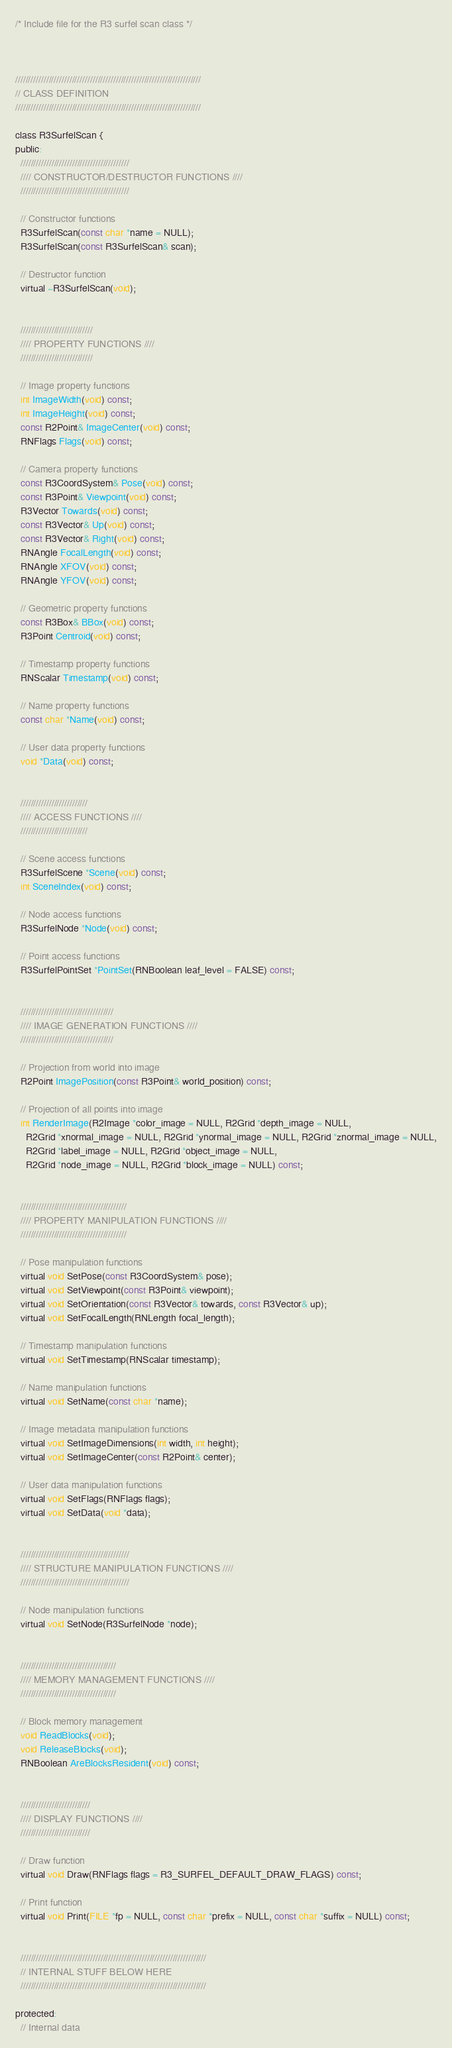Convert code to text. <code><loc_0><loc_0><loc_500><loc_500><_C_>/* Include file for the R3 surfel scan class */



////////////////////////////////////////////////////////////////////////
// CLASS DEFINITION
////////////////////////////////////////////////////////////////////////

class R3SurfelScan {
public:
  //////////////////////////////////////////
  //// CONSTRUCTOR/DESTRUCTOR FUNCTIONS ////
  //////////////////////////////////////////

  // Constructor functions
  R3SurfelScan(const char *name = NULL);
  R3SurfelScan(const R3SurfelScan& scan);

  // Destructor function
  virtual ~R3SurfelScan(void);


  ////////////////////////////
  //// PROPERTY FUNCTIONS ////
  ////////////////////////////

  // Image property functions
  int ImageWidth(void) const;
  int ImageHeight(void) const;
  const R2Point& ImageCenter(void) const;
  RNFlags Flags(void) const;
  
  // Camera property functions
  const R3CoordSystem& Pose(void) const;
  const R3Point& Viewpoint(void) const;
  R3Vector Towards(void) const;
  const R3Vector& Up(void) const;
  const R3Vector& Right(void) const;
  RNAngle FocalLength(void) const;
  RNAngle XFOV(void) const;
  RNAngle YFOV(void) const;

  // Geometric property functions
  const R3Box& BBox(void) const;
  R3Point Centroid(void) const;

  // Timestamp property functions
  RNScalar Timestamp(void) const;

  // Name property functions
  const char *Name(void) const;

  // User data property functions
  void *Data(void) const;


  //////////////////////////
  //// ACCESS FUNCTIONS ////
  //////////////////////////

  // Scene access functions
  R3SurfelScene *Scene(void) const;
  int SceneIndex(void) const;

  // Node access functions
  R3SurfelNode *Node(void) const;

  // Point access functions
  R3SurfelPointSet *PointSet(RNBoolean leaf_level = FALSE) const;


  ////////////////////////////////////
  //// IMAGE GENERATION FUNCTIONS ////
  ////////////////////////////////////

  // Projection from world into image
  R2Point ImagePosition(const R3Point& world_position) const;

  // Projection of all points into image
  int RenderImage(R2Image *color_image = NULL, R2Grid *depth_image = NULL,
    R2Grid *xnormal_image = NULL, R2Grid *ynormal_image = NULL, R2Grid *znormal_image = NULL,
    R2Grid *label_image = NULL, R2Grid *object_image = NULL,
    R2Grid *node_image = NULL, R2Grid *block_image = NULL) const;

  
  /////////////////////////////////////////
  //// PROPERTY MANIPULATION FUNCTIONS ////
  /////////////////////////////////////////

  // Pose manipulation functions
  virtual void SetPose(const R3CoordSystem& pose);
  virtual void SetViewpoint(const R3Point& viewpoint);
  virtual void SetOrientation(const R3Vector& towards, const R3Vector& up);
  virtual void SetFocalLength(RNLength focal_length);

  // Timestamp manipulation functions
  virtual void SetTimestamp(RNScalar timestamp);

  // Name manipulation functions
  virtual void SetName(const char *name);

  // Image metadata manipulation functions
  virtual void SetImageDimensions(int width, int height);
  virtual void SetImageCenter(const R2Point& center);

  // User data manipulation functions
  virtual void SetFlags(RNFlags flags);
  virtual void SetData(void *data);


  //////////////////////////////////////////
  //// STRUCTURE MANIPULATION FUNCTIONS ////
  //////////////////////////////////////////

  // Node manipulation functions
  virtual void SetNode(R3SurfelNode *node);


  /////////////////////////////////////
  //// MEMORY MANAGEMENT FUNCTIONS ////
  /////////////////////////////////////

  // Block memory management
  void ReadBlocks(void);
  void ReleaseBlocks(void);
  RNBoolean AreBlocksResident(void) const;


  ///////////////////////////
  //// DISPLAY FUNCTIONS ////
  ///////////////////////////

  // Draw function
  virtual void Draw(RNFlags flags = R3_SURFEL_DEFAULT_DRAW_FLAGS) const;

  // Print function
  virtual void Print(FILE *fp = NULL, const char *prefix = NULL, const char *suffix = NULL) const;


  ////////////////////////////////////////////////////////////////////////
  // INTERNAL STUFF BELOW HERE
  ////////////////////////////////////////////////////////////////////////

protected:
  // Internal data</code> 